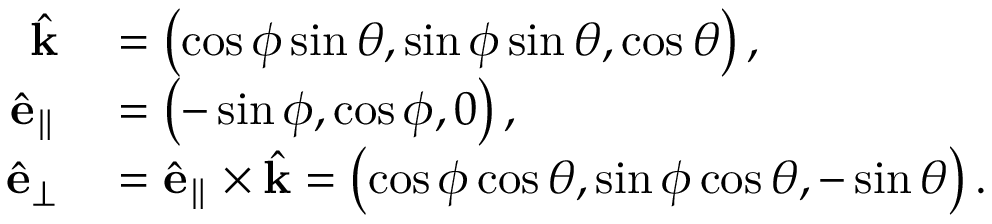<formula> <loc_0><loc_0><loc_500><loc_500>\begin{array} { r l } { \hat { k } } & = \left ( \cos \phi \sin \theta , \sin \phi \sin \theta , \cos \theta \right ) , } \\ { \hat { e } _ { \| } } & = \left ( - \sin \phi , \cos \phi , 0 \right ) , } \\ { \hat { e } _ { \perp } } & = \hat { e } _ { \| } \times \hat { k } = \left ( \cos \phi \cos \theta , \sin \phi \cos \theta , - \sin \theta \right ) . } \end{array}</formula> 